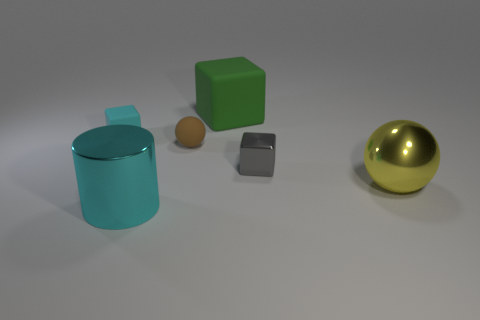What is the color of the large thing that is to the right of the brown thing and in front of the rubber sphere?
Provide a succinct answer. Yellow. There is a block that is in front of the cyan matte cube; is there a big green matte thing behind it?
Make the answer very short. Yes. Are there the same number of shiny cylinders that are on the right side of the large cyan thing and yellow balls?
Offer a terse response. No. There is a cyan object in front of the large yellow metallic object that is to the right of the small ball; what number of cylinders are behind it?
Offer a terse response. 0. Are there any yellow things that have the same size as the green cube?
Offer a very short reply. Yes. Are there fewer shiny objects left of the big cyan object than gray metal blocks?
Give a very brief answer. Yes. There is a small cube right of the cyan cylinder in front of the cyan object behind the big cyan object; what is it made of?
Your answer should be very brief. Metal. Are there more large metal objects that are behind the large shiny ball than cyan cylinders that are in front of the big cyan cylinder?
Offer a very short reply. No. What number of metallic things are small cyan things or tiny blue blocks?
Ensure brevity in your answer.  0. There is a object that is the same color as the large cylinder; what is its shape?
Your response must be concise. Cube. 